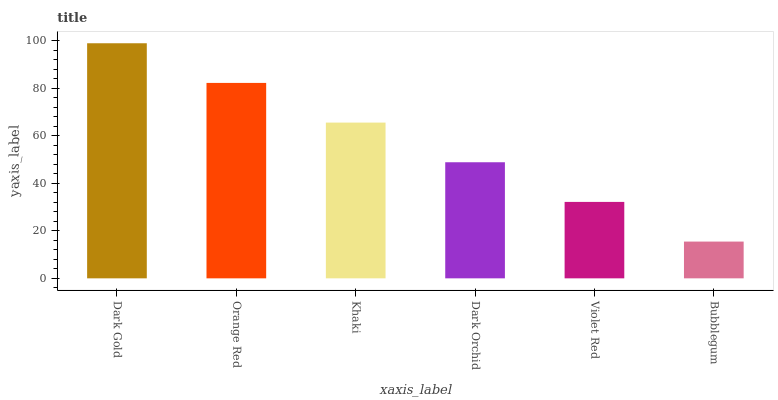Is Bubblegum the minimum?
Answer yes or no. Yes. Is Dark Gold the maximum?
Answer yes or no. Yes. Is Orange Red the minimum?
Answer yes or no. No. Is Orange Red the maximum?
Answer yes or no. No. Is Dark Gold greater than Orange Red?
Answer yes or no. Yes. Is Orange Red less than Dark Gold?
Answer yes or no. Yes. Is Orange Red greater than Dark Gold?
Answer yes or no. No. Is Dark Gold less than Orange Red?
Answer yes or no. No. Is Khaki the high median?
Answer yes or no. Yes. Is Dark Orchid the low median?
Answer yes or no. Yes. Is Dark Gold the high median?
Answer yes or no. No. Is Khaki the low median?
Answer yes or no. No. 